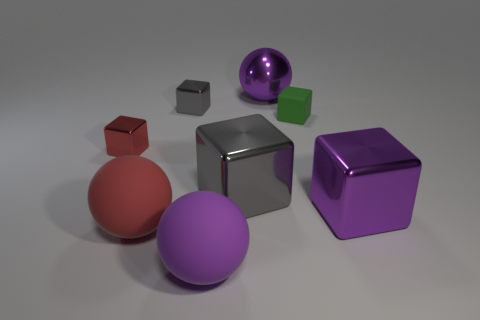Subtract all big cubes. How many cubes are left? 3 Subtract all green blocks. How many blocks are left? 4 Add 2 large blocks. How many objects exist? 10 Subtract 2 balls. How many balls are left? 1 Subtract all yellow spheres. Subtract all red cylinders. How many spheres are left? 3 Subtract all brown cylinders. How many yellow balls are left? 0 Subtract all matte balls. Subtract all big red blocks. How many objects are left? 6 Add 1 large metallic spheres. How many large metallic spheres are left? 2 Add 3 cyan rubber blocks. How many cyan rubber blocks exist? 3 Subtract 0 cyan spheres. How many objects are left? 8 